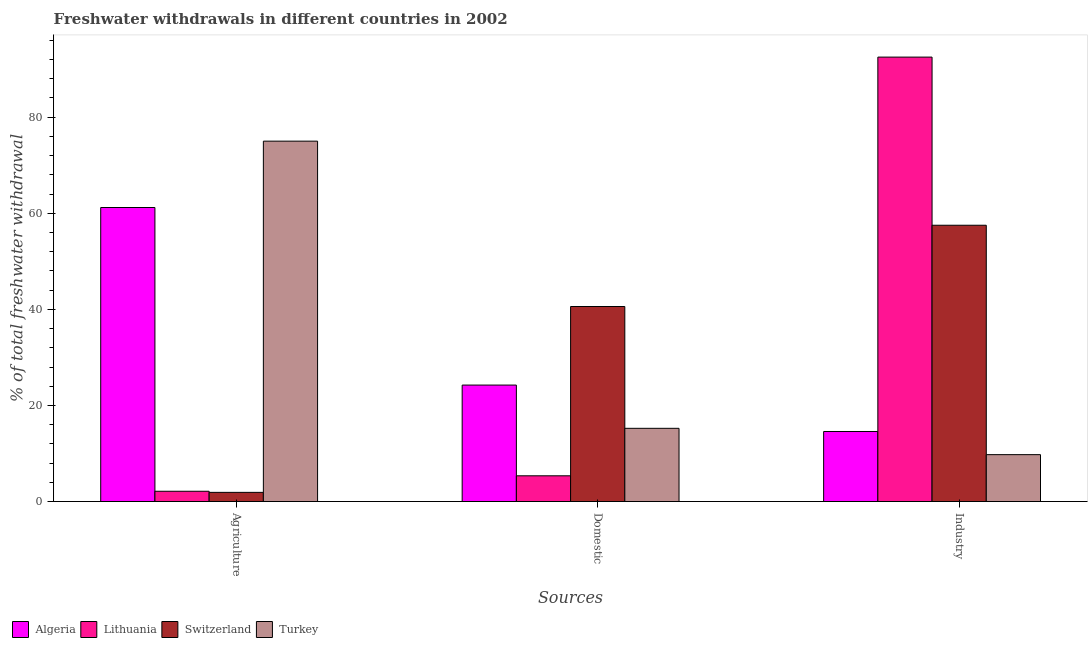What is the label of the 1st group of bars from the left?
Keep it short and to the point. Agriculture. What is the percentage of freshwater withdrawal for industry in Lithuania?
Offer a very short reply. 92.49. Across all countries, what is the maximum percentage of freshwater withdrawal for domestic purposes?
Your answer should be compact. 40.59. Across all countries, what is the minimum percentage of freshwater withdrawal for industry?
Your response must be concise. 9.76. In which country was the percentage of freshwater withdrawal for agriculture maximum?
Provide a short and direct response. Turkey. In which country was the percentage of freshwater withdrawal for agriculture minimum?
Keep it short and to the point. Switzerland. What is the total percentage of freshwater withdrawal for industry in the graph?
Your answer should be very brief. 174.33. What is the difference between the percentage of freshwater withdrawal for domestic purposes in Lithuania and that in Switzerland?
Keep it short and to the point. -35.23. What is the difference between the percentage of freshwater withdrawal for agriculture in Switzerland and the percentage of freshwater withdrawal for domestic purposes in Lithuania?
Provide a short and direct response. -3.45. What is the average percentage of freshwater withdrawal for industry per country?
Ensure brevity in your answer.  43.58. What is the difference between the percentage of freshwater withdrawal for industry and percentage of freshwater withdrawal for agriculture in Switzerland?
Provide a succinct answer. 55.59. What is the ratio of the percentage of freshwater withdrawal for domestic purposes in Lithuania to that in Turkey?
Make the answer very short. 0.35. Is the difference between the percentage of freshwater withdrawal for domestic purposes in Turkey and Lithuania greater than the difference between the percentage of freshwater withdrawal for agriculture in Turkey and Lithuania?
Provide a short and direct response. No. What is the difference between the highest and the second highest percentage of freshwater withdrawal for agriculture?
Make the answer very short. 13.81. What is the difference between the highest and the lowest percentage of freshwater withdrawal for domestic purposes?
Give a very brief answer. 35.23. In how many countries, is the percentage of freshwater withdrawal for agriculture greater than the average percentage of freshwater withdrawal for agriculture taken over all countries?
Make the answer very short. 2. Is the sum of the percentage of freshwater withdrawal for domestic purposes in Turkey and Switzerland greater than the maximum percentage of freshwater withdrawal for industry across all countries?
Provide a short and direct response. No. What does the 4th bar from the left in Domestic represents?
Ensure brevity in your answer.  Turkey. What does the 4th bar from the right in Agriculture represents?
Give a very brief answer. Algeria. Does the graph contain any zero values?
Your answer should be very brief. No. Does the graph contain grids?
Provide a succinct answer. No. Where does the legend appear in the graph?
Offer a very short reply. Bottom left. How many legend labels are there?
Your answer should be very brief. 4. How are the legend labels stacked?
Keep it short and to the point. Horizontal. What is the title of the graph?
Offer a very short reply. Freshwater withdrawals in different countries in 2002. Does "Palau" appear as one of the legend labels in the graph?
Offer a very short reply. No. What is the label or title of the X-axis?
Offer a very short reply. Sources. What is the label or title of the Y-axis?
Provide a succinct answer. % of total freshwater withdrawal. What is the % of total freshwater withdrawal of Algeria in Agriculture?
Keep it short and to the point. 61.19. What is the % of total freshwater withdrawal of Lithuania in Agriculture?
Provide a short and direct response. 2.14. What is the % of total freshwater withdrawal in Switzerland in Agriculture?
Give a very brief answer. 1.91. What is the % of total freshwater withdrawal of Algeria in Domestic?
Make the answer very short. 24.24. What is the % of total freshwater withdrawal in Lithuania in Domestic?
Provide a short and direct response. 5.36. What is the % of total freshwater withdrawal of Switzerland in Domestic?
Ensure brevity in your answer.  40.59. What is the % of total freshwater withdrawal of Turkey in Domestic?
Offer a terse response. 15.24. What is the % of total freshwater withdrawal in Algeria in Industry?
Keep it short and to the point. 14.58. What is the % of total freshwater withdrawal in Lithuania in Industry?
Your answer should be compact. 92.49. What is the % of total freshwater withdrawal in Switzerland in Industry?
Offer a very short reply. 57.5. What is the % of total freshwater withdrawal in Turkey in Industry?
Provide a succinct answer. 9.76. Across all Sources, what is the maximum % of total freshwater withdrawal in Algeria?
Provide a short and direct response. 61.19. Across all Sources, what is the maximum % of total freshwater withdrawal in Lithuania?
Your answer should be compact. 92.49. Across all Sources, what is the maximum % of total freshwater withdrawal in Switzerland?
Provide a short and direct response. 57.5. Across all Sources, what is the maximum % of total freshwater withdrawal of Turkey?
Your answer should be compact. 75. Across all Sources, what is the minimum % of total freshwater withdrawal in Algeria?
Offer a terse response. 14.58. Across all Sources, what is the minimum % of total freshwater withdrawal in Lithuania?
Offer a terse response. 2.14. Across all Sources, what is the minimum % of total freshwater withdrawal of Switzerland?
Your answer should be compact. 1.91. Across all Sources, what is the minimum % of total freshwater withdrawal in Turkey?
Offer a very short reply. 9.76. What is the total % of total freshwater withdrawal of Algeria in the graph?
Offer a terse response. 100.01. What is the total % of total freshwater withdrawal of Lithuania in the graph?
Your answer should be compact. 100. What is the total % of total freshwater withdrawal in Switzerland in the graph?
Ensure brevity in your answer.  100. What is the total % of total freshwater withdrawal of Turkey in the graph?
Your answer should be compact. 100. What is the difference between the % of total freshwater withdrawal of Algeria in Agriculture and that in Domestic?
Make the answer very short. 36.95. What is the difference between the % of total freshwater withdrawal of Lithuania in Agriculture and that in Domestic?
Ensure brevity in your answer.  -3.22. What is the difference between the % of total freshwater withdrawal of Switzerland in Agriculture and that in Domestic?
Offer a very short reply. -38.68. What is the difference between the % of total freshwater withdrawal in Turkey in Agriculture and that in Domestic?
Your response must be concise. 59.76. What is the difference between the % of total freshwater withdrawal in Algeria in Agriculture and that in Industry?
Your answer should be compact. 46.61. What is the difference between the % of total freshwater withdrawal of Lithuania in Agriculture and that in Industry?
Provide a succinct answer. -90.35. What is the difference between the % of total freshwater withdrawal of Switzerland in Agriculture and that in Industry?
Offer a very short reply. -55.59. What is the difference between the % of total freshwater withdrawal of Turkey in Agriculture and that in Industry?
Provide a succinct answer. 65.24. What is the difference between the % of total freshwater withdrawal of Algeria in Domestic and that in Industry?
Your answer should be very brief. 9.66. What is the difference between the % of total freshwater withdrawal of Lithuania in Domestic and that in Industry?
Ensure brevity in your answer.  -87.13. What is the difference between the % of total freshwater withdrawal in Switzerland in Domestic and that in Industry?
Offer a terse response. -16.91. What is the difference between the % of total freshwater withdrawal of Turkey in Domestic and that in Industry?
Your response must be concise. 5.48. What is the difference between the % of total freshwater withdrawal of Algeria in Agriculture and the % of total freshwater withdrawal of Lithuania in Domestic?
Provide a succinct answer. 55.83. What is the difference between the % of total freshwater withdrawal in Algeria in Agriculture and the % of total freshwater withdrawal in Switzerland in Domestic?
Give a very brief answer. 20.6. What is the difference between the % of total freshwater withdrawal of Algeria in Agriculture and the % of total freshwater withdrawal of Turkey in Domestic?
Your response must be concise. 45.95. What is the difference between the % of total freshwater withdrawal of Lithuania in Agriculture and the % of total freshwater withdrawal of Switzerland in Domestic?
Your answer should be very brief. -38.45. What is the difference between the % of total freshwater withdrawal of Lithuania in Agriculture and the % of total freshwater withdrawal of Turkey in Domestic?
Your answer should be very brief. -13.1. What is the difference between the % of total freshwater withdrawal in Switzerland in Agriculture and the % of total freshwater withdrawal in Turkey in Domestic?
Your answer should be very brief. -13.33. What is the difference between the % of total freshwater withdrawal of Algeria in Agriculture and the % of total freshwater withdrawal of Lithuania in Industry?
Provide a succinct answer. -31.3. What is the difference between the % of total freshwater withdrawal of Algeria in Agriculture and the % of total freshwater withdrawal of Switzerland in Industry?
Your answer should be very brief. 3.69. What is the difference between the % of total freshwater withdrawal of Algeria in Agriculture and the % of total freshwater withdrawal of Turkey in Industry?
Offer a terse response. 51.43. What is the difference between the % of total freshwater withdrawal of Lithuania in Agriculture and the % of total freshwater withdrawal of Switzerland in Industry?
Ensure brevity in your answer.  -55.36. What is the difference between the % of total freshwater withdrawal of Lithuania in Agriculture and the % of total freshwater withdrawal of Turkey in Industry?
Your answer should be very brief. -7.62. What is the difference between the % of total freshwater withdrawal of Switzerland in Agriculture and the % of total freshwater withdrawal of Turkey in Industry?
Keep it short and to the point. -7.85. What is the difference between the % of total freshwater withdrawal in Algeria in Domestic and the % of total freshwater withdrawal in Lithuania in Industry?
Make the answer very short. -68.25. What is the difference between the % of total freshwater withdrawal of Algeria in Domestic and the % of total freshwater withdrawal of Switzerland in Industry?
Provide a succinct answer. -33.26. What is the difference between the % of total freshwater withdrawal in Algeria in Domestic and the % of total freshwater withdrawal in Turkey in Industry?
Keep it short and to the point. 14.48. What is the difference between the % of total freshwater withdrawal of Lithuania in Domestic and the % of total freshwater withdrawal of Switzerland in Industry?
Make the answer very short. -52.14. What is the difference between the % of total freshwater withdrawal in Lithuania in Domestic and the % of total freshwater withdrawal in Turkey in Industry?
Offer a very short reply. -4.4. What is the difference between the % of total freshwater withdrawal of Switzerland in Domestic and the % of total freshwater withdrawal of Turkey in Industry?
Offer a very short reply. 30.83. What is the average % of total freshwater withdrawal in Algeria per Sources?
Your response must be concise. 33.34. What is the average % of total freshwater withdrawal in Lithuania per Sources?
Provide a short and direct response. 33.33. What is the average % of total freshwater withdrawal in Switzerland per Sources?
Your answer should be compact. 33.33. What is the average % of total freshwater withdrawal of Turkey per Sources?
Your response must be concise. 33.33. What is the difference between the % of total freshwater withdrawal of Algeria and % of total freshwater withdrawal of Lithuania in Agriculture?
Ensure brevity in your answer.  59.05. What is the difference between the % of total freshwater withdrawal in Algeria and % of total freshwater withdrawal in Switzerland in Agriculture?
Provide a short and direct response. 59.28. What is the difference between the % of total freshwater withdrawal in Algeria and % of total freshwater withdrawal in Turkey in Agriculture?
Your response must be concise. -13.81. What is the difference between the % of total freshwater withdrawal of Lithuania and % of total freshwater withdrawal of Switzerland in Agriculture?
Provide a short and direct response. 0.23. What is the difference between the % of total freshwater withdrawal of Lithuania and % of total freshwater withdrawal of Turkey in Agriculture?
Give a very brief answer. -72.86. What is the difference between the % of total freshwater withdrawal of Switzerland and % of total freshwater withdrawal of Turkey in Agriculture?
Give a very brief answer. -73.09. What is the difference between the % of total freshwater withdrawal of Algeria and % of total freshwater withdrawal of Lithuania in Domestic?
Offer a terse response. 18.88. What is the difference between the % of total freshwater withdrawal in Algeria and % of total freshwater withdrawal in Switzerland in Domestic?
Offer a terse response. -16.35. What is the difference between the % of total freshwater withdrawal of Algeria and % of total freshwater withdrawal of Turkey in Domestic?
Offer a terse response. 9. What is the difference between the % of total freshwater withdrawal of Lithuania and % of total freshwater withdrawal of Switzerland in Domestic?
Make the answer very short. -35.23. What is the difference between the % of total freshwater withdrawal in Lithuania and % of total freshwater withdrawal in Turkey in Domestic?
Keep it short and to the point. -9.88. What is the difference between the % of total freshwater withdrawal of Switzerland and % of total freshwater withdrawal of Turkey in Domestic?
Your response must be concise. 25.35. What is the difference between the % of total freshwater withdrawal in Algeria and % of total freshwater withdrawal in Lithuania in Industry?
Ensure brevity in your answer.  -77.91. What is the difference between the % of total freshwater withdrawal in Algeria and % of total freshwater withdrawal in Switzerland in Industry?
Your answer should be compact. -42.92. What is the difference between the % of total freshwater withdrawal of Algeria and % of total freshwater withdrawal of Turkey in Industry?
Your response must be concise. 4.82. What is the difference between the % of total freshwater withdrawal of Lithuania and % of total freshwater withdrawal of Switzerland in Industry?
Make the answer very short. 34.99. What is the difference between the % of total freshwater withdrawal in Lithuania and % of total freshwater withdrawal in Turkey in Industry?
Keep it short and to the point. 82.73. What is the difference between the % of total freshwater withdrawal of Switzerland and % of total freshwater withdrawal of Turkey in Industry?
Your response must be concise. 47.74. What is the ratio of the % of total freshwater withdrawal of Algeria in Agriculture to that in Domestic?
Give a very brief answer. 2.52. What is the ratio of the % of total freshwater withdrawal in Lithuania in Agriculture to that in Domestic?
Offer a very short reply. 0.4. What is the ratio of the % of total freshwater withdrawal of Switzerland in Agriculture to that in Domestic?
Your answer should be compact. 0.05. What is the ratio of the % of total freshwater withdrawal in Turkey in Agriculture to that in Domestic?
Your answer should be very brief. 4.92. What is the ratio of the % of total freshwater withdrawal in Algeria in Agriculture to that in Industry?
Your answer should be compact. 4.2. What is the ratio of the % of total freshwater withdrawal in Lithuania in Agriculture to that in Industry?
Provide a short and direct response. 0.02. What is the ratio of the % of total freshwater withdrawal of Turkey in Agriculture to that in Industry?
Provide a succinct answer. 7.68. What is the ratio of the % of total freshwater withdrawal in Algeria in Domestic to that in Industry?
Offer a very short reply. 1.66. What is the ratio of the % of total freshwater withdrawal of Lithuania in Domestic to that in Industry?
Offer a terse response. 0.06. What is the ratio of the % of total freshwater withdrawal in Switzerland in Domestic to that in Industry?
Give a very brief answer. 0.71. What is the ratio of the % of total freshwater withdrawal in Turkey in Domestic to that in Industry?
Give a very brief answer. 1.56. What is the difference between the highest and the second highest % of total freshwater withdrawal in Algeria?
Make the answer very short. 36.95. What is the difference between the highest and the second highest % of total freshwater withdrawal in Lithuania?
Ensure brevity in your answer.  87.13. What is the difference between the highest and the second highest % of total freshwater withdrawal in Switzerland?
Keep it short and to the point. 16.91. What is the difference between the highest and the second highest % of total freshwater withdrawal in Turkey?
Make the answer very short. 59.76. What is the difference between the highest and the lowest % of total freshwater withdrawal in Algeria?
Ensure brevity in your answer.  46.61. What is the difference between the highest and the lowest % of total freshwater withdrawal of Lithuania?
Give a very brief answer. 90.35. What is the difference between the highest and the lowest % of total freshwater withdrawal of Switzerland?
Your answer should be compact. 55.59. What is the difference between the highest and the lowest % of total freshwater withdrawal in Turkey?
Provide a succinct answer. 65.24. 